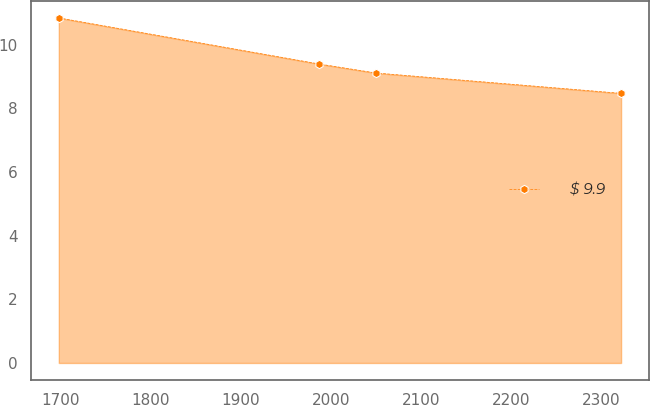Convert chart to OTSL. <chart><loc_0><loc_0><loc_500><loc_500><line_chart><ecel><fcel>$ 9.9<nl><fcel>1697.7<fcel>10.84<nl><fcel>1986.98<fcel>9.39<nl><fcel>2049.37<fcel>9.11<nl><fcel>2321.64<fcel>8.47<nl></chart> 